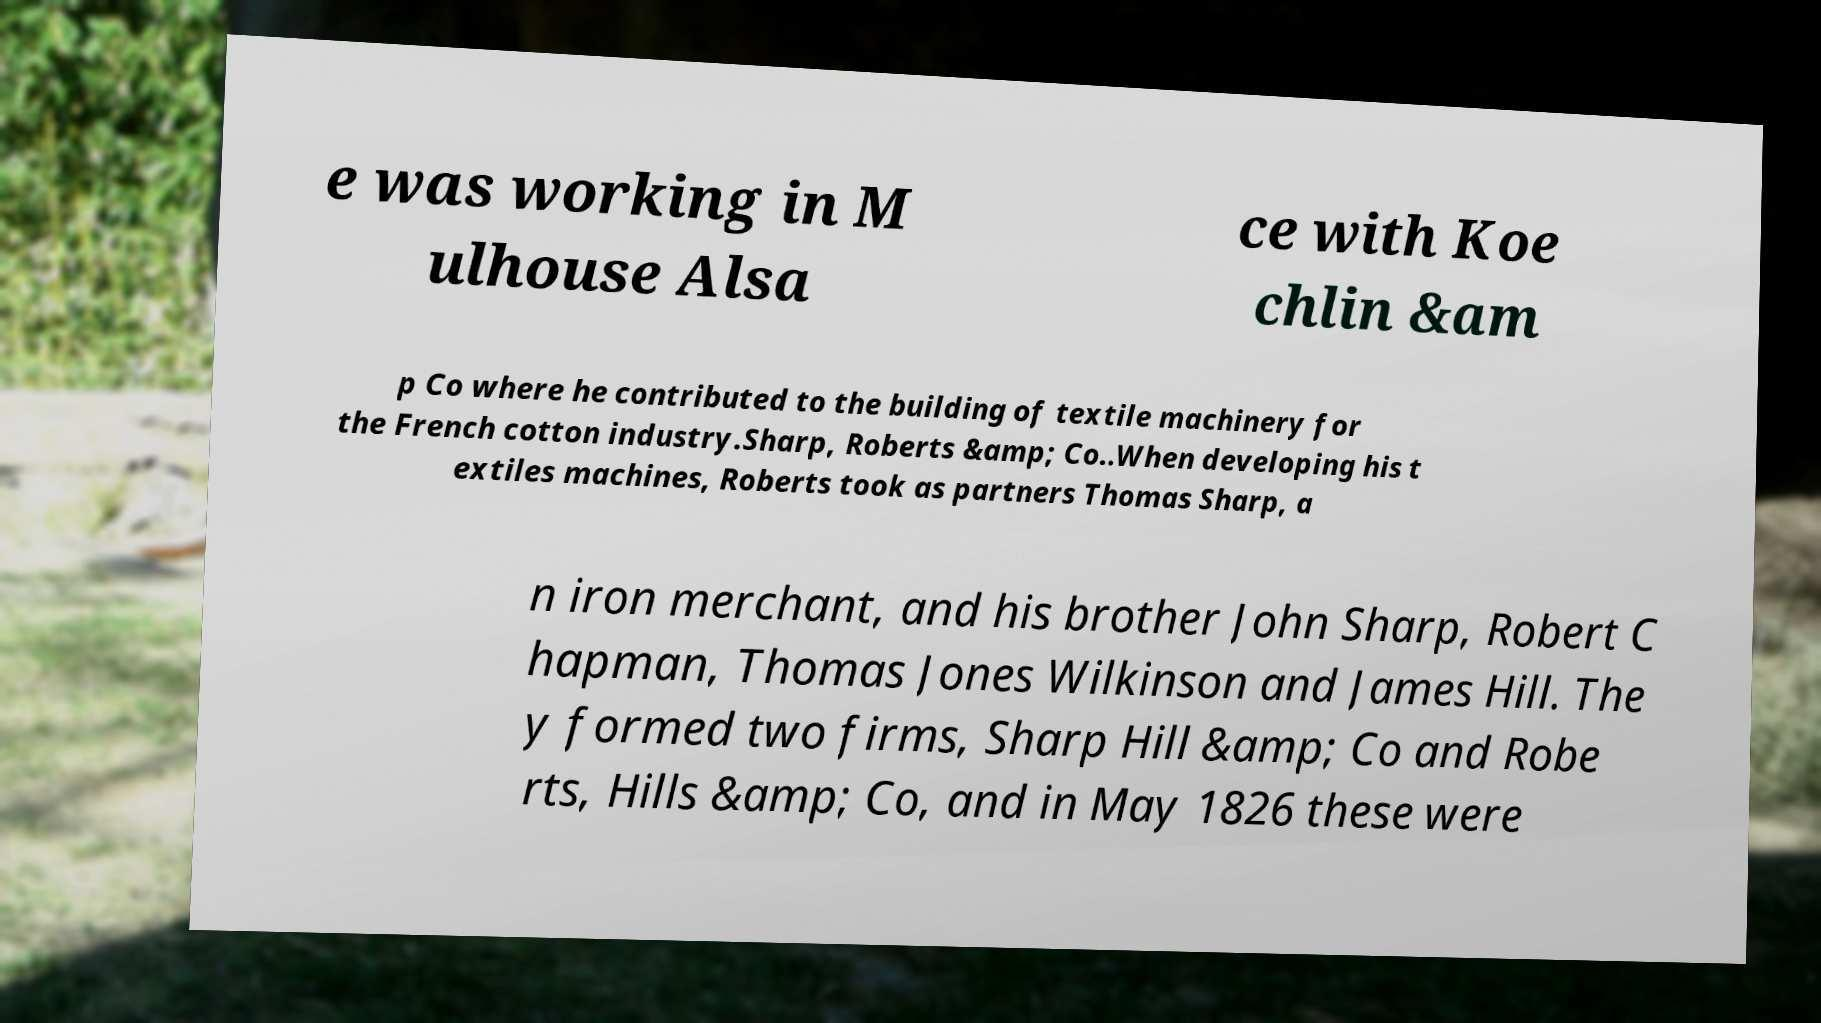Could you assist in decoding the text presented in this image and type it out clearly? e was working in M ulhouse Alsa ce with Koe chlin &am p Co where he contributed to the building of textile machinery for the French cotton industry.Sharp, Roberts &amp; Co..When developing his t extiles machines, Roberts took as partners Thomas Sharp, a n iron merchant, and his brother John Sharp, Robert C hapman, Thomas Jones Wilkinson and James Hill. The y formed two firms, Sharp Hill &amp; Co and Robe rts, Hills &amp; Co, and in May 1826 these were 